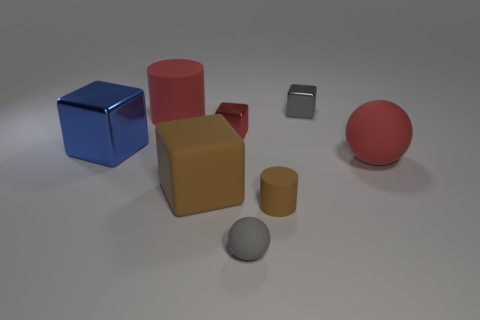Add 2 yellow matte things. How many objects exist? 10 Subtract all spheres. How many objects are left? 6 Subtract all brown things. Subtract all big red shiny objects. How many objects are left? 6 Add 5 rubber spheres. How many rubber spheres are left? 7 Add 5 small green shiny blocks. How many small green shiny blocks exist? 5 Subtract 0 purple spheres. How many objects are left? 8 